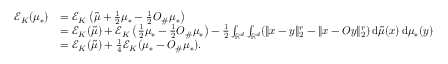<formula> <loc_0><loc_0><loc_500><loc_500>\begin{array} { r l } { \mathcal { E } _ { K } ( \mu _ { * } ) } & { = \mathcal { E } _ { K } \left ( \tilde { \mu } + \frac { 1 } { 2 } \mu _ { * } - \frac { 1 } { 2 } O _ { \# } \mu _ { * } \right ) } \\ & { = \mathcal { E } _ { K } ( \tilde { \mu } ) + \mathcal { E } _ { K } \left ( \frac { 1 } { 2 } \mu _ { * } - \frac { 1 } { 2 } O _ { \# } \mu _ { * } \right ) - \frac { 1 } { 2 } \int _ { \mathbb { R } ^ { d } } \int _ { \mathbb { R } ^ { d } } ( \| x - y \| _ { 2 } ^ { r } - \| x - O y \| _ { 2 } ^ { r } ) \, d \tilde { \mu } ( x ) \, d \mu _ { * } ( y ) } \\ & { = \mathcal { E } _ { K } ( \tilde { \mu } ) + \frac { 1 } { 4 } \mathcal { E } _ { K } ( \mu _ { * } - O _ { \# } \mu _ { * } ) . } \end{array}</formula> 